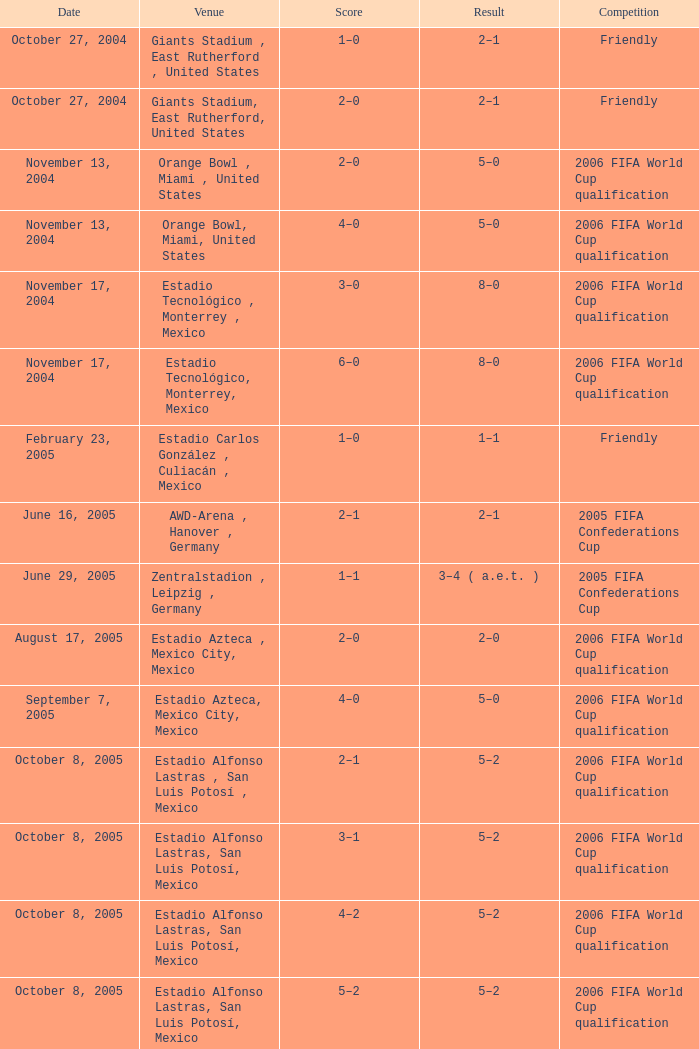Help me parse the entirety of this table. {'header': ['Date', 'Venue', 'Score', 'Result', 'Competition'], 'rows': [['October 27, 2004', 'Giants Stadium , East Rutherford , United States', '1–0', '2–1', 'Friendly'], ['October 27, 2004', 'Giants Stadium, East Rutherford, United States', '2–0', '2–1', 'Friendly'], ['November 13, 2004', 'Orange Bowl , Miami , United States', '2–0', '5–0', '2006 FIFA World Cup qualification'], ['November 13, 2004', 'Orange Bowl, Miami, United States', '4–0', '5–0', '2006 FIFA World Cup qualification'], ['November 17, 2004', 'Estadio Tecnológico , Monterrey , Mexico', '3–0', '8–0', '2006 FIFA World Cup qualification'], ['November 17, 2004', 'Estadio Tecnológico, Monterrey, Mexico', '6–0', '8–0', '2006 FIFA World Cup qualification'], ['February 23, 2005', 'Estadio Carlos González , Culiacán , Mexico', '1–0', '1–1', 'Friendly'], ['June 16, 2005', 'AWD-Arena , Hanover , Germany', '2–1', '2–1', '2005 FIFA Confederations Cup'], ['June 29, 2005', 'Zentralstadion , Leipzig , Germany', '1–1', '3–4 ( a.e.t. )', '2005 FIFA Confederations Cup'], ['August 17, 2005', 'Estadio Azteca , Mexico City, Mexico', '2–0', '2–0', '2006 FIFA World Cup qualification'], ['September 7, 2005', 'Estadio Azteca, Mexico City, Mexico', '4–0', '5–0', '2006 FIFA World Cup qualification'], ['October 8, 2005', 'Estadio Alfonso Lastras , San Luis Potosí , Mexico', '2–1', '5–2', '2006 FIFA World Cup qualification'], ['October 8, 2005', 'Estadio Alfonso Lastras, San Luis Potosí, Mexico', '3–1', '5–2', '2006 FIFA World Cup qualification'], ['October 8, 2005', 'Estadio Alfonso Lastras, San Luis Potosí, Mexico', '4–2', '5–2', '2006 FIFA World Cup qualification'], ['October 8, 2005', 'Estadio Alfonso Lastras, San Luis Potosí, Mexico', '5–2', '5–2', '2006 FIFA World Cup qualification'], ['December 14, 2005', 'Chase Field , Phoenix , United States', '1–0', '2–0', 'Friendly'], ['January 25, 2006', 'Monster Park , San Francisco , United States', '1–1', '2–1', 'Friendly'], ['May 12, 2006', 'Estadio Azteca, Mexico City, Mexico', '1–0', '2–1', 'Friendly'], ['May 12, 2006', 'Estadio Azteca, Mexico City, Mexico', '2–0', '2–1', 'Friendly'], ['June 21, 2006', 'Veltins-Arena , Gelsenkirchen , Germany', '1–2', '1–2', '2006 FIFA World Cup'], ['June 2, 2007', 'Estadio Alfonso Lastras, San Luis Potosí, Mexico', '3–0', '4–0', 'Friendly']]} Which Score has a Result of 2–1, and a Competition of friendly, and a Goal smaller than 17? 1–0, 2–0. 